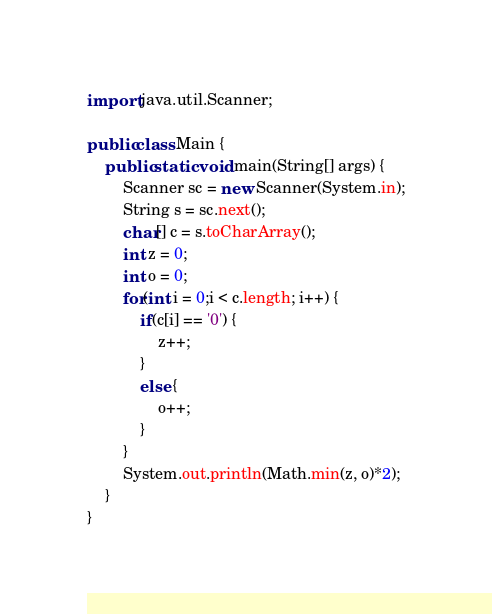Convert code to text. <code><loc_0><loc_0><loc_500><loc_500><_Java_>import java.util.Scanner;

public class Main {
	public static void main(String[] args) {
		Scanner sc = new Scanner(System.in);
		String s = sc.next();
		char[] c = s.toCharArray();
		int z = 0;
		int o = 0;
		for(int i = 0;i < c.length; i++) {
			if(c[i] == '0') {
				z++;
			}
			else {
				o++;
			}
		}
		System.out.println(Math.min(z, o)*2);
	}
}
</code> 